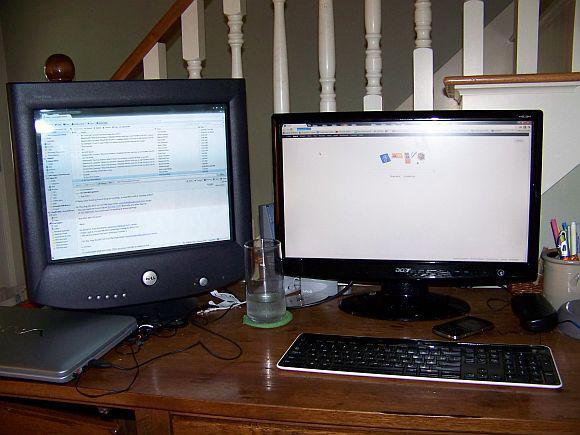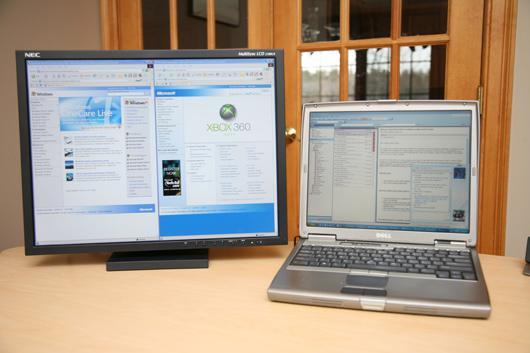The first image is the image on the left, the second image is the image on the right. Examine the images to the left and right. Is the description "The desktop is visible on the screen." accurate? Answer yes or no. No. 